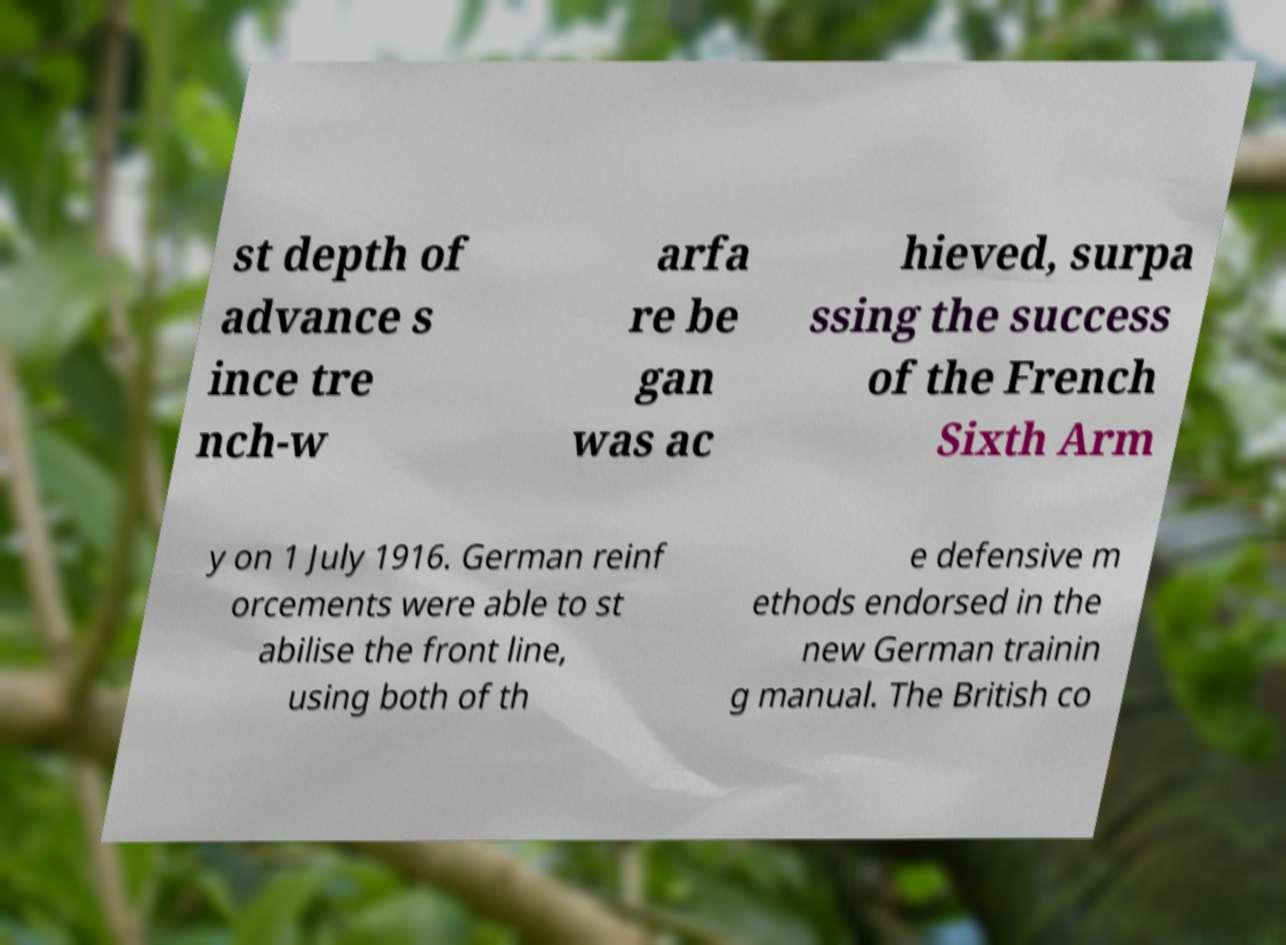Can you accurately transcribe the text from the provided image for me? st depth of advance s ince tre nch-w arfa re be gan was ac hieved, surpa ssing the success of the French Sixth Arm y on 1 July 1916. German reinf orcements were able to st abilise the front line, using both of th e defensive m ethods endorsed in the new German trainin g manual. The British co 